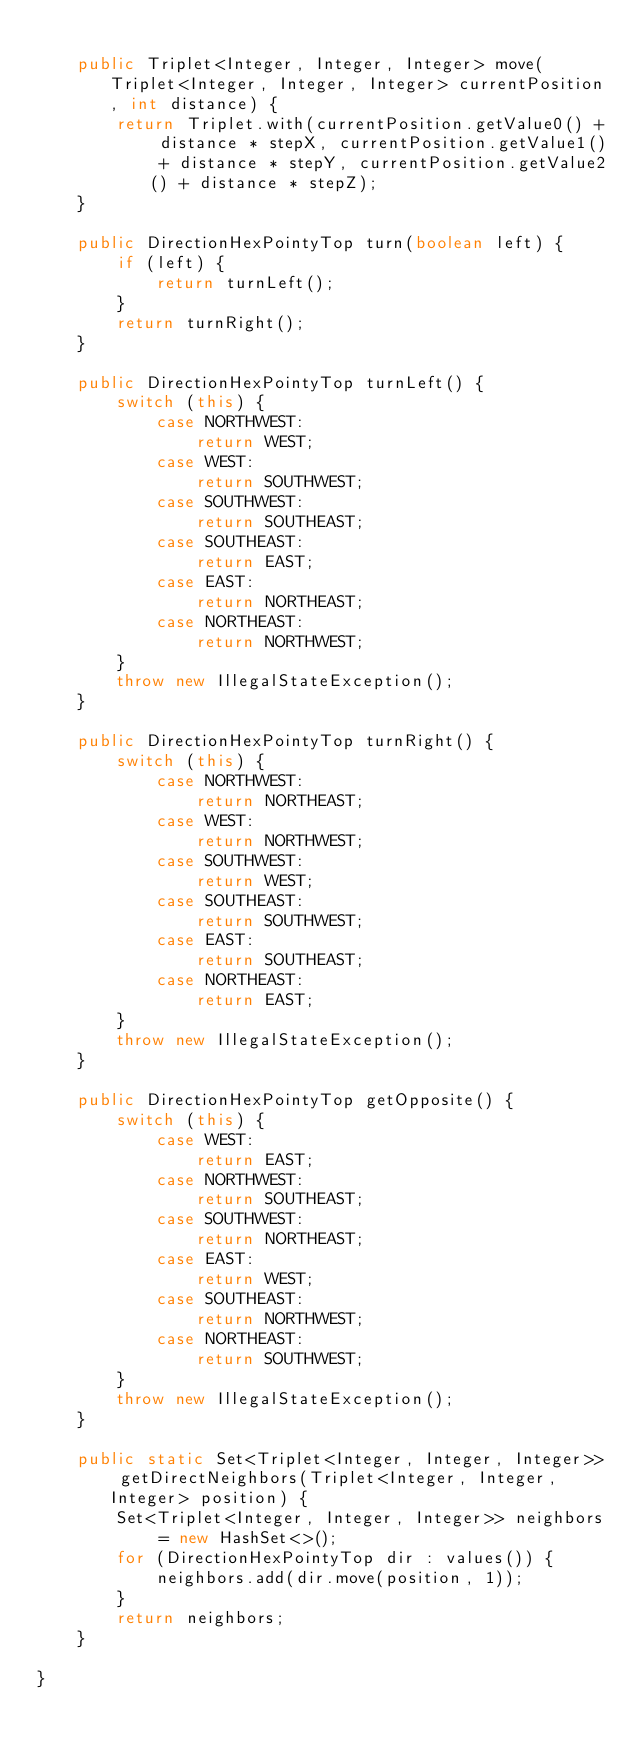Convert code to text. <code><loc_0><loc_0><loc_500><loc_500><_Java_>
    public Triplet<Integer, Integer, Integer> move(Triplet<Integer, Integer, Integer> currentPosition, int distance) {
        return Triplet.with(currentPosition.getValue0() + distance * stepX, currentPosition.getValue1() + distance * stepY, currentPosition.getValue2() + distance * stepZ);
    }

    public DirectionHexPointyTop turn(boolean left) {
        if (left) {
            return turnLeft();
        }
        return turnRight();
    }

    public DirectionHexPointyTop turnLeft() {
        switch (this) {
            case NORTHWEST:
                return WEST;
            case WEST:
                return SOUTHWEST;
            case SOUTHWEST:
                return SOUTHEAST;
            case SOUTHEAST:
                return EAST;
            case EAST:
                return NORTHEAST;
            case NORTHEAST:
                return NORTHWEST;
        }
        throw new IllegalStateException();
    }

    public DirectionHexPointyTop turnRight() {
        switch (this) {
            case NORTHWEST:
                return NORTHEAST;
            case WEST:
                return NORTHWEST;
            case SOUTHWEST:
                return WEST;
            case SOUTHEAST:
                return SOUTHWEST;
            case EAST:
                return SOUTHEAST;
            case NORTHEAST:
                return EAST;
        }
        throw new IllegalStateException();
    }

    public DirectionHexPointyTop getOpposite() {
        switch (this) {
            case WEST:
                return EAST;
            case NORTHWEST:
                return SOUTHEAST;
            case SOUTHWEST:
                return NORTHEAST;
            case EAST:
                return WEST;
            case SOUTHEAST:
                return NORTHWEST;
            case NORTHEAST:
                return SOUTHWEST;
        }
        throw new IllegalStateException();
    }

    public static Set<Triplet<Integer, Integer, Integer>> getDirectNeighbors(Triplet<Integer, Integer, Integer> position) {
        Set<Triplet<Integer, Integer, Integer>> neighbors = new HashSet<>();
        for (DirectionHexPointyTop dir : values()) {
            neighbors.add(dir.move(position, 1));
        }
        return neighbors;
    }

}
</code> 